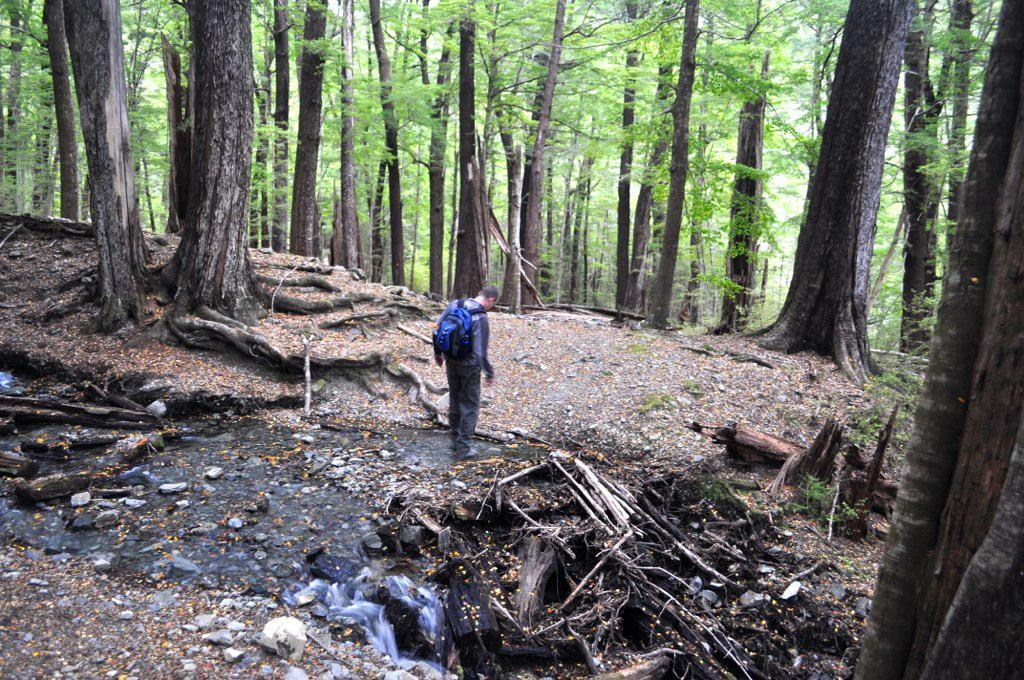What can be seen in the image? There is a person in the image, and they are wearing a backpack. What is the person doing in the image? The person is standing in the image. What is the natural environment like in the image? There is water, wooden logs, stones, and many trees visible in the image. What type of pet is the person exchanging with their friend in the image? There is no pet or exchange present in the image; it only shows a person standing with a backpack in a natural environment. 